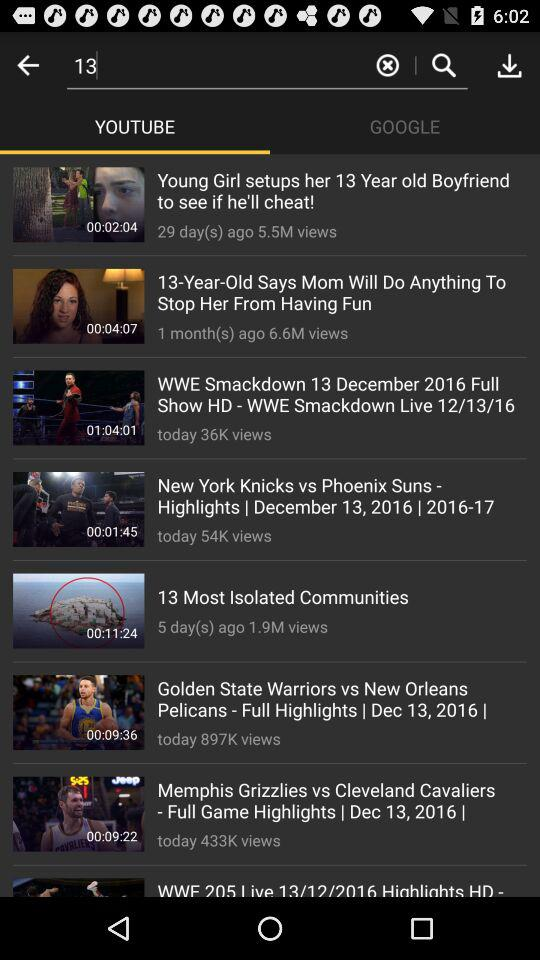What is the duration of the "Golden State Warriors vs. New Orleans Pelicans"? The duration is 00:09:36. 